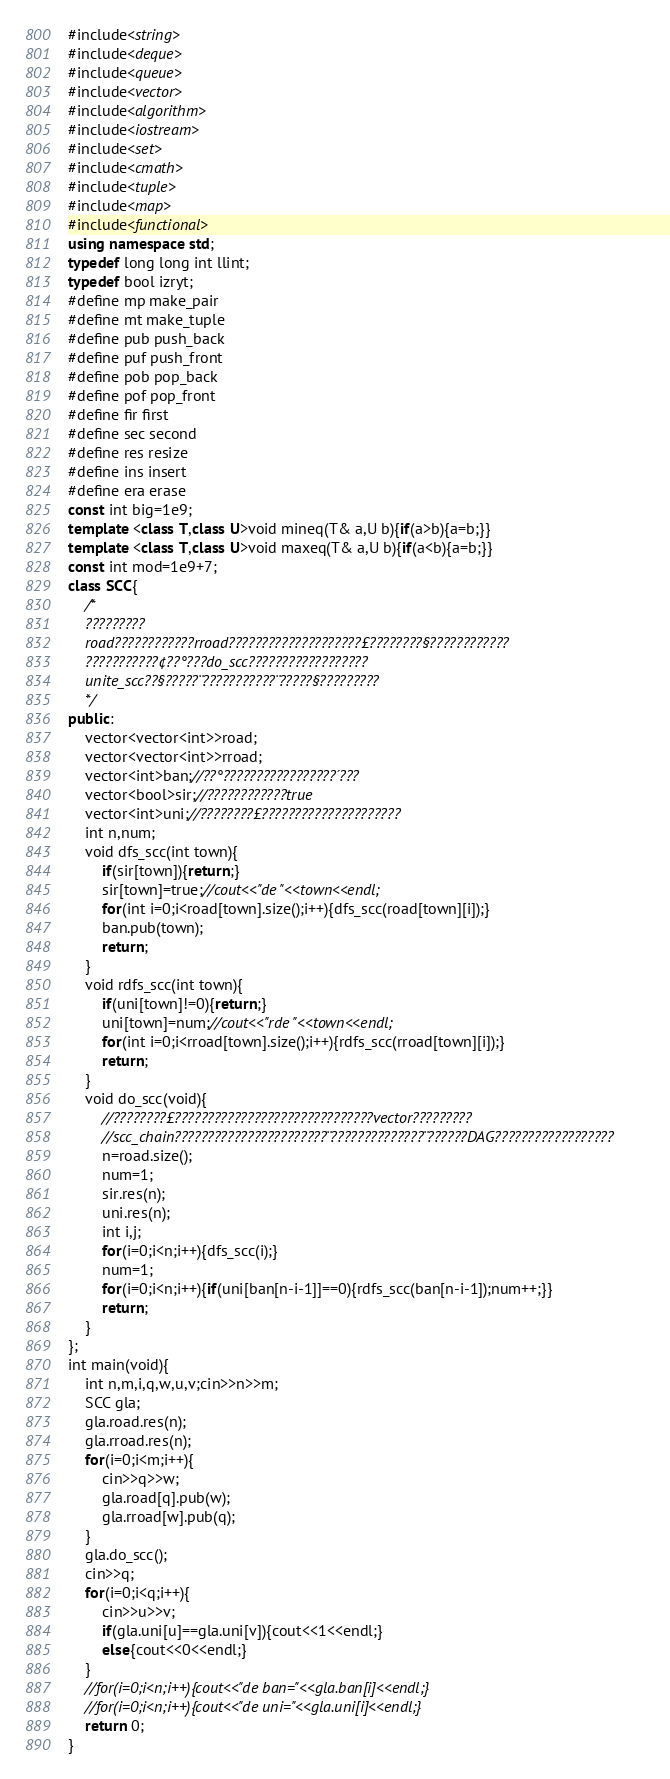<code> <loc_0><loc_0><loc_500><loc_500><_C++_>#include<string>
#include<deque>
#include<queue>
#include<vector>
#include<algorithm>
#include<iostream>
#include<set>
#include<cmath>
#include<tuple>
#include<map>
#include<functional>
using namespace std;
typedef long long int llint;
typedef bool izryt;
#define mp make_pair
#define mt make_tuple
#define pub push_back
#define puf push_front
#define pob pop_back
#define pof pop_front
#define fir first
#define sec second
#define res resize
#define ins insert
#define era erase
const int big=1e9;
template <class T,class U>void mineq(T& a,U b){if(a>b){a=b;}}
template <class T,class U>void maxeq(T& a,U b){if(a<b){a=b;}}
const int mod=1e9+7;
class SCC{
	/*
	?????????
	road????????????rroad????????????????????£????????§????????????
	???????????¢??°???do_scc??????????????????
	unite_scc??§?????¨???????????¨?????§?????????
	*/
public:
	vector<vector<int>>road;
	vector<vector<int>>rroad;
	vector<int>ban;//??°?????????????????´???
	vector<bool>sir;//????????????true
	vector<int>uni;//????????£?????????????????????
	int n,num;
	void dfs_scc(int town){
		if(sir[town]){return;}
		sir[town]=true;//cout<<"de "<<town<<endl;
		for(int i=0;i<road[town].size();i++){dfs_scc(road[town][i]);}
		ban.pub(town);
		return;
	}
	void rdfs_scc(int town){
		if(uni[town]!=0){return;}
		uni[town]=num;//cout<<"rde "<<town<<endl;
		for(int i=0;i<rroad[town].size();i++){rdfs_scc(rroad[town][i]);}
		return;
	}
	void do_scc(void){
		//????????£??????????????????????????????vector?????????
		//scc_chain???????????????????????¨??????????????¨??????DAG??????????????????
		n=road.size();
		num=1;
		sir.res(n);
		uni.res(n);
		int i,j;
		for(i=0;i<n;i++){dfs_scc(i);}
		num=1;
		for(i=0;i<n;i++){if(uni[ban[n-i-1]]==0){rdfs_scc(ban[n-i-1]);num++;}}
		return;
	}
};
int main(void){
	int n,m,i,q,w,u,v;cin>>n>>m;
	SCC gla;
	gla.road.res(n);
	gla.rroad.res(n);
	for(i=0;i<m;i++){
		cin>>q>>w;
		gla.road[q].pub(w);
		gla.rroad[w].pub(q);
	}
	gla.do_scc();
	cin>>q;
	for(i=0;i<q;i++){
		cin>>u>>v;
		if(gla.uni[u]==gla.uni[v]){cout<<1<<endl;}
		else{cout<<0<<endl;}
	}
	//for(i=0;i<n;i++){cout<<"de ban="<<gla.ban[i]<<endl;}
	//for(i=0;i<n;i++){cout<<"de uni="<<gla.uni[i]<<endl;}
	return 0;
}</code> 